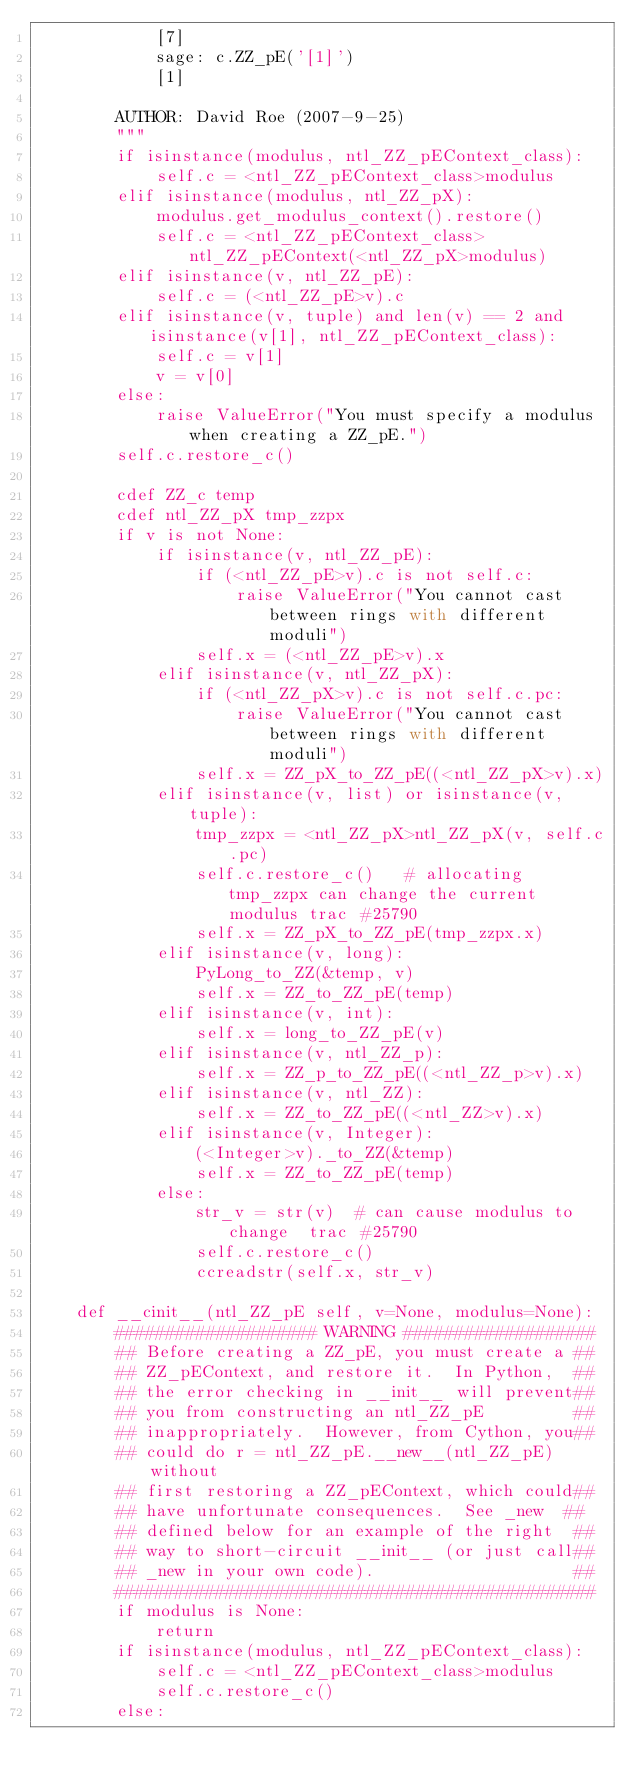Convert code to text. <code><loc_0><loc_0><loc_500><loc_500><_Cython_>            [7]
            sage: c.ZZ_pE('[1]')
            [1]

        AUTHOR: David Roe (2007-9-25)
        """
        if isinstance(modulus, ntl_ZZ_pEContext_class):
            self.c = <ntl_ZZ_pEContext_class>modulus
        elif isinstance(modulus, ntl_ZZ_pX):
            modulus.get_modulus_context().restore()
            self.c = <ntl_ZZ_pEContext_class>ntl_ZZ_pEContext(<ntl_ZZ_pX>modulus)
        elif isinstance(v, ntl_ZZ_pE):
            self.c = (<ntl_ZZ_pE>v).c
        elif isinstance(v, tuple) and len(v) == 2 and isinstance(v[1], ntl_ZZ_pEContext_class):
            self.c = v[1]
            v = v[0]
        else:
            raise ValueError("You must specify a modulus when creating a ZZ_pE.")
        self.c.restore_c()

        cdef ZZ_c temp
        cdef ntl_ZZ_pX tmp_zzpx
        if v is not None:
            if isinstance(v, ntl_ZZ_pE):
                if (<ntl_ZZ_pE>v).c is not self.c:
                    raise ValueError("You cannot cast between rings with different moduli")
                self.x = (<ntl_ZZ_pE>v).x
            elif isinstance(v, ntl_ZZ_pX):
                if (<ntl_ZZ_pX>v).c is not self.c.pc:
                    raise ValueError("You cannot cast between rings with different moduli")
                self.x = ZZ_pX_to_ZZ_pE((<ntl_ZZ_pX>v).x)
            elif isinstance(v, list) or isinstance(v, tuple):
                tmp_zzpx = <ntl_ZZ_pX>ntl_ZZ_pX(v, self.c.pc)
                self.c.restore_c()   # allocating tmp_zzpx can change the current modulus trac #25790
                self.x = ZZ_pX_to_ZZ_pE(tmp_zzpx.x)
            elif isinstance(v, long):
                PyLong_to_ZZ(&temp, v)
                self.x = ZZ_to_ZZ_pE(temp)
            elif isinstance(v, int):
                self.x = long_to_ZZ_pE(v)
            elif isinstance(v, ntl_ZZ_p):
                self.x = ZZ_p_to_ZZ_pE((<ntl_ZZ_p>v).x)
            elif isinstance(v, ntl_ZZ):
                self.x = ZZ_to_ZZ_pE((<ntl_ZZ>v).x)
            elif isinstance(v, Integer):
                (<Integer>v)._to_ZZ(&temp)
                self.x = ZZ_to_ZZ_pE(temp)
            else:
                str_v = str(v)  # can cause modulus to change  trac #25790
                self.c.restore_c()
                ccreadstr(self.x, str_v)

    def __cinit__(ntl_ZZ_pE self, v=None, modulus=None):
        #################### WARNING ###################
        ## Before creating a ZZ_pE, you must create a ##
        ## ZZ_pEContext, and restore it.  In Python,  ##
        ## the error checking in __init__ will prevent##
        ## you from constructing an ntl_ZZ_pE         ##
        ## inappropriately.  However, from Cython, you##
        ## could do r = ntl_ZZ_pE.__new__(ntl_ZZ_pE) without
        ## first restoring a ZZ_pEContext, which could##
        ## have unfortunate consequences.  See _new  ##
        ## defined below for an example of the right  ##
        ## way to short-circuit __init__ (or just call##
        ## _new in your own code).                    ##
        ################################################
        if modulus is None:
            return
        if isinstance(modulus, ntl_ZZ_pEContext_class):
            self.c = <ntl_ZZ_pEContext_class>modulus
            self.c.restore_c()
        else:</code> 